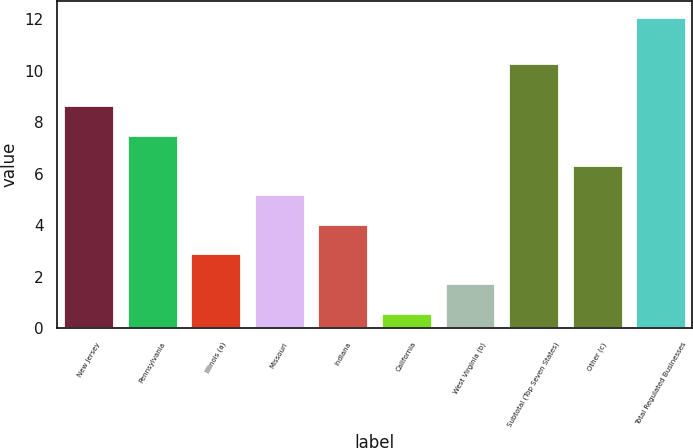Convert chart. <chart><loc_0><loc_0><loc_500><loc_500><bar_chart><fcel>New Jersey<fcel>Pennsylvania<fcel>Illinois (a)<fcel>Missouri<fcel>Indiana<fcel>California<fcel>West Virginia (b)<fcel>Subtotal (Top Seven States)<fcel>Other (c)<fcel>Total Regulated Businesses<nl><fcel>8.65<fcel>7.5<fcel>2.9<fcel>5.2<fcel>4.05<fcel>0.6<fcel>1.75<fcel>10.3<fcel>6.35<fcel>12.1<nl></chart> 